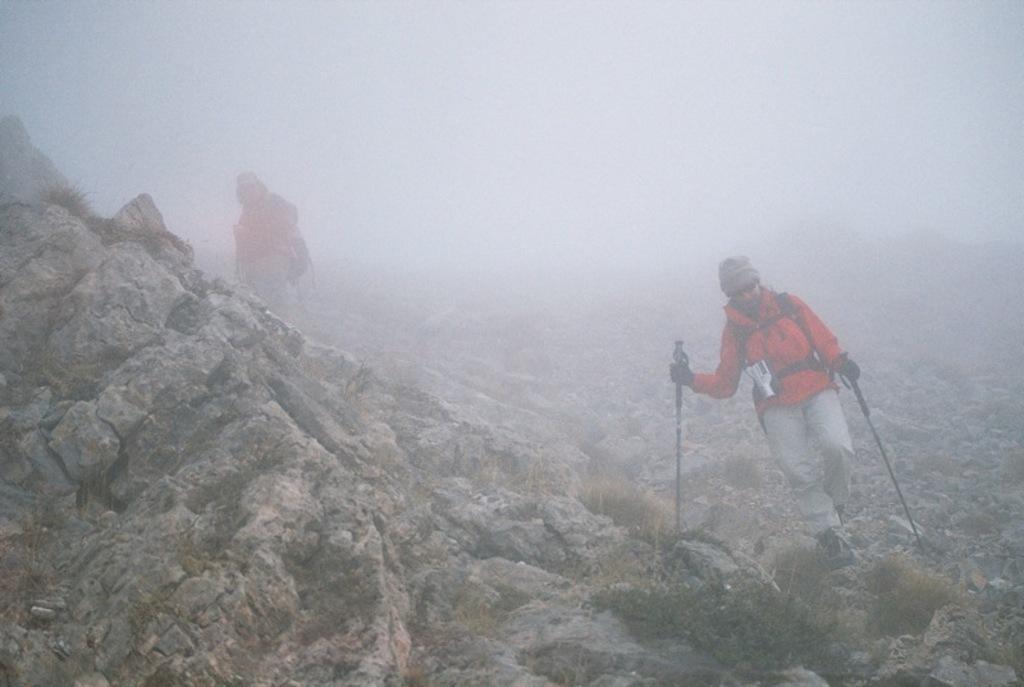Describe this image in one or two sentences. In this image two persons are walking on a mountain. 